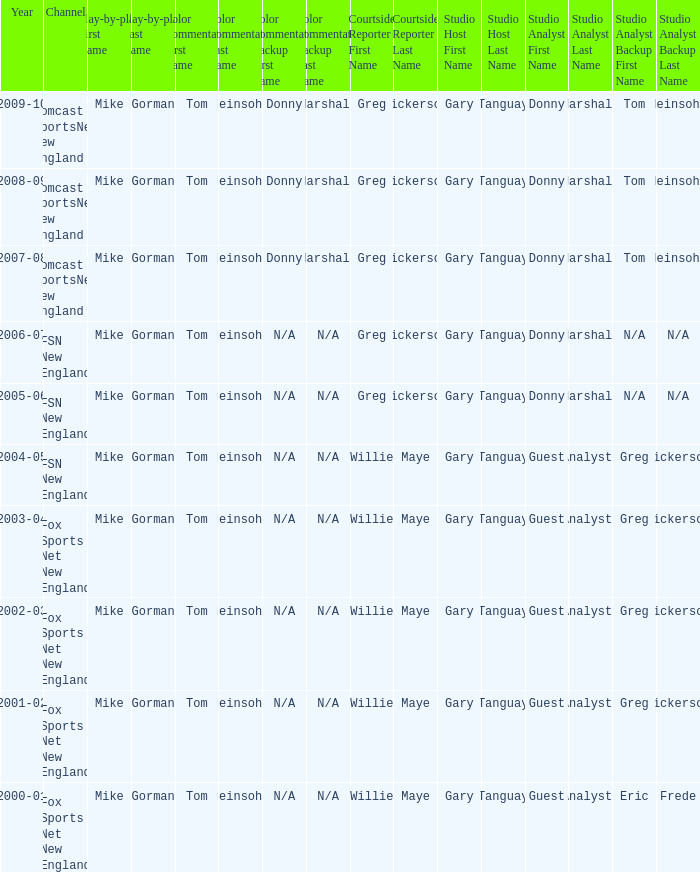Who is the color commentator that works with gary tanguay and eric frede as studio hosts? Tom Heinsohn. 